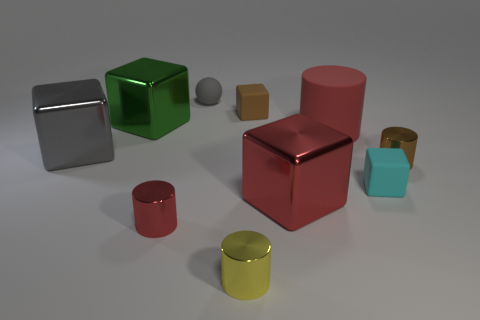Is there any other thing of the same color as the large cylinder?
Ensure brevity in your answer.  Yes. There is a cyan thing that is the same shape as the green shiny thing; what material is it?
Keep it short and to the point. Rubber. There is a red matte thing; are there any rubber objects in front of it?
Give a very brief answer. Yes. How many big yellow shiny cylinders are there?
Ensure brevity in your answer.  0. How many things are behind the small brown thing right of the cyan block?
Give a very brief answer. 5. There is a small rubber sphere; does it have the same color as the large shiny cube that is left of the green block?
Offer a terse response. Yes. How many big rubber things have the same shape as the small brown metallic object?
Your response must be concise. 1. What material is the gray thing on the right side of the gray metallic thing?
Your answer should be very brief. Rubber. Does the green object left of the small red shiny cylinder have the same shape as the small brown matte object?
Keep it short and to the point. Yes. Is there a gray shiny cylinder that has the same size as the matte cylinder?
Provide a succinct answer. No. 